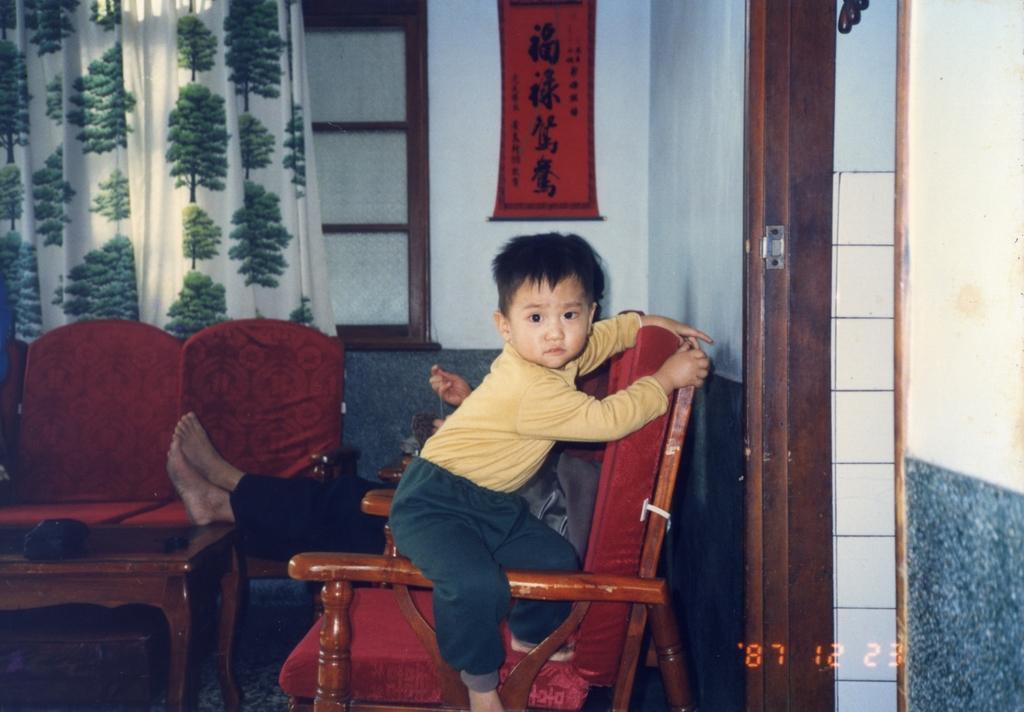How would you summarize this image in a sentence or two? In this picture a boy is sitting on the sofa and a person is sitting behind him, in the background there is a window and a curtain and also a calendar on the wall. 